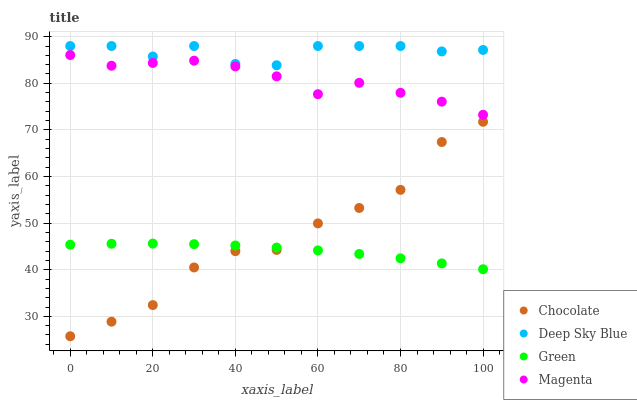Does Green have the minimum area under the curve?
Answer yes or no. Yes. Does Deep Sky Blue have the maximum area under the curve?
Answer yes or no. Yes. Does Deep Sky Blue have the minimum area under the curve?
Answer yes or no. No. Does Green have the maximum area under the curve?
Answer yes or no. No. Is Green the smoothest?
Answer yes or no. Yes. Is Chocolate the roughest?
Answer yes or no. Yes. Is Deep Sky Blue the smoothest?
Answer yes or no. No. Is Deep Sky Blue the roughest?
Answer yes or no. No. Does Chocolate have the lowest value?
Answer yes or no. Yes. Does Green have the lowest value?
Answer yes or no. No. Does Deep Sky Blue have the highest value?
Answer yes or no. Yes. Does Green have the highest value?
Answer yes or no. No. Is Magenta less than Deep Sky Blue?
Answer yes or no. Yes. Is Magenta greater than Chocolate?
Answer yes or no. Yes. Does Green intersect Chocolate?
Answer yes or no. Yes. Is Green less than Chocolate?
Answer yes or no. No. Is Green greater than Chocolate?
Answer yes or no. No. Does Magenta intersect Deep Sky Blue?
Answer yes or no. No. 